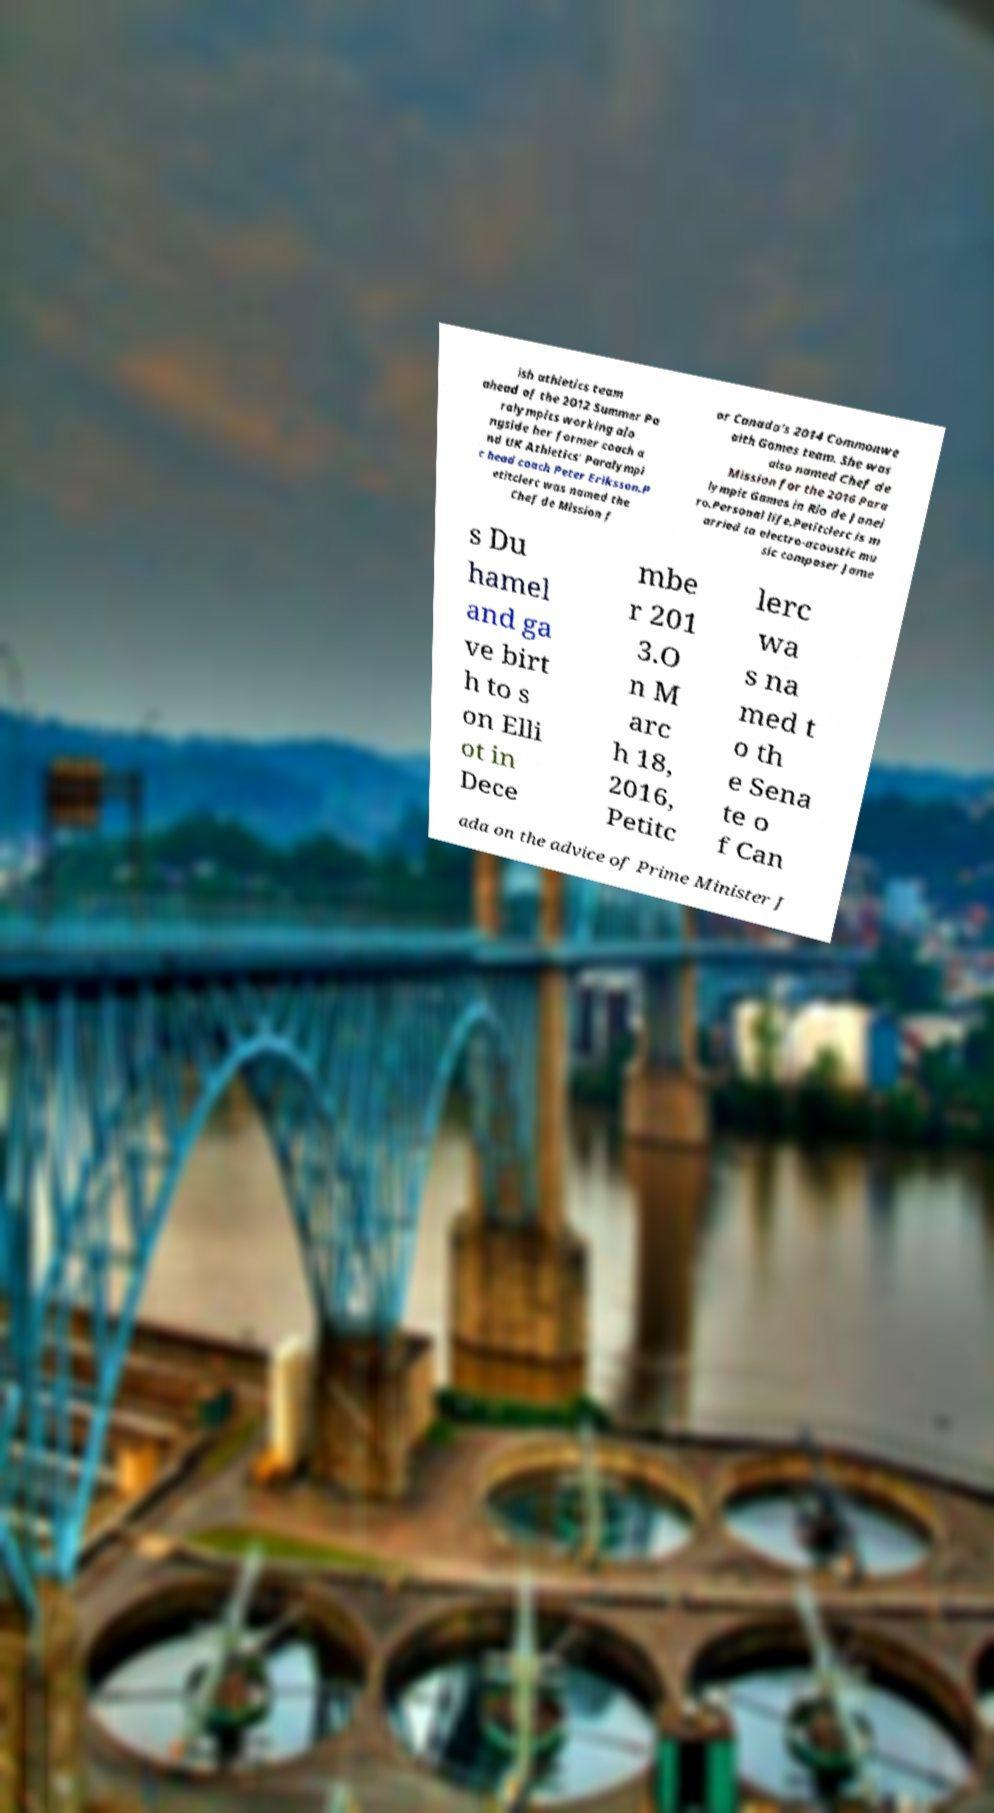Can you accurately transcribe the text from the provided image for me? ish athletics team ahead of the 2012 Summer Pa ralympics working alo ngside her former coach a nd UK Athletics' Paralympi c head coach Peter Eriksson.P etitclerc was named the Chef de Mission f or Canada's 2014 Commonwe alth Games team. She was also named Chef de Mission for the 2016 Para lympic Games in Rio de Janei ro.Personal life.Petitclerc is m arried to electro-acoustic mu sic composer Jame s Du hamel and ga ve birt h to s on Elli ot in Dece mbe r 201 3.O n M arc h 18, 2016, Petitc lerc wa s na med t o th e Sena te o f Can ada on the advice of Prime Minister J 